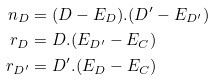<formula> <loc_0><loc_0><loc_500><loc_500>n _ { D } & = ( D - E _ { D } ) . ( D ^ { \prime } - E _ { D ^ { \prime } } ) \\ r _ { D } & = D . ( E _ { D ^ { \prime } } - E _ { C } ) \\ r _ { D ^ { \prime } } & = D ^ { \prime } . ( E _ { D } - E _ { C } )</formula> 